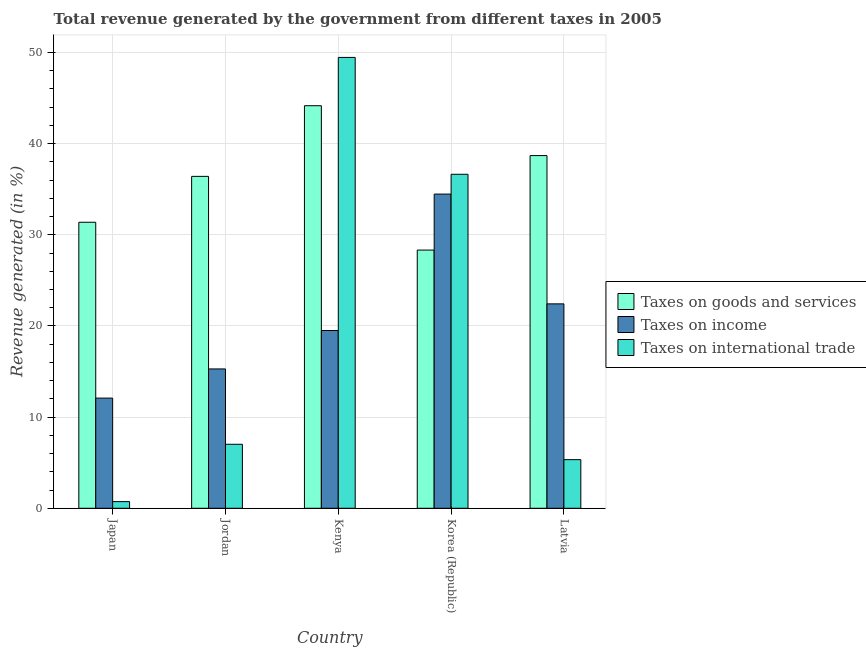How many groups of bars are there?
Give a very brief answer. 5. Are the number of bars per tick equal to the number of legend labels?
Give a very brief answer. Yes. How many bars are there on the 2nd tick from the left?
Keep it short and to the point. 3. How many bars are there on the 1st tick from the right?
Make the answer very short. 3. What is the percentage of revenue generated by taxes on income in Korea (Republic)?
Your answer should be compact. 34.46. Across all countries, what is the maximum percentage of revenue generated by taxes on income?
Offer a very short reply. 34.46. Across all countries, what is the minimum percentage of revenue generated by tax on international trade?
Ensure brevity in your answer.  0.73. In which country was the percentage of revenue generated by tax on international trade maximum?
Your answer should be very brief. Kenya. What is the total percentage of revenue generated by taxes on goods and services in the graph?
Give a very brief answer. 178.95. What is the difference between the percentage of revenue generated by tax on international trade in Japan and that in Korea (Republic)?
Offer a terse response. -35.91. What is the difference between the percentage of revenue generated by taxes on goods and services in Kenya and the percentage of revenue generated by taxes on income in Japan?
Your response must be concise. 32.07. What is the average percentage of revenue generated by taxes on goods and services per country?
Offer a terse response. 35.79. What is the difference between the percentage of revenue generated by taxes on goods and services and percentage of revenue generated by tax on international trade in Latvia?
Provide a succinct answer. 33.35. What is the ratio of the percentage of revenue generated by tax on international trade in Jordan to that in Kenya?
Provide a short and direct response. 0.14. Is the percentage of revenue generated by taxes on goods and services in Kenya less than that in Latvia?
Make the answer very short. No. Is the difference between the percentage of revenue generated by taxes on goods and services in Jordan and Korea (Republic) greater than the difference between the percentage of revenue generated by tax on international trade in Jordan and Korea (Republic)?
Provide a short and direct response. Yes. What is the difference between the highest and the second highest percentage of revenue generated by taxes on goods and services?
Your response must be concise. 5.47. What is the difference between the highest and the lowest percentage of revenue generated by tax on international trade?
Your answer should be very brief. 48.72. Is the sum of the percentage of revenue generated by taxes on goods and services in Japan and Jordan greater than the maximum percentage of revenue generated by taxes on income across all countries?
Provide a succinct answer. Yes. What does the 1st bar from the left in Latvia represents?
Ensure brevity in your answer.  Taxes on goods and services. What does the 3rd bar from the right in Latvia represents?
Your response must be concise. Taxes on goods and services. Is it the case that in every country, the sum of the percentage of revenue generated by taxes on goods and services and percentage of revenue generated by taxes on income is greater than the percentage of revenue generated by tax on international trade?
Provide a short and direct response. Yes. How many bars are there?
Offer a very short reply. 15. Are all the bars in the graph horizontal?
Give a very brief answer. No. How many countries are there in the graph?
Your response must be concise. 5. What is the difference between two consecutive major ticks on the Y-axis?
Offer a very short reply. 10. Are the values on the major ticks of Y-axis written in scientific E-notation?
Your answer should be compact. No. Does the graph contain grids?
Offer a very short reply. Yes. Where does the legend appear in the graph?
Provide a short and direct response. Center right. How many legend labels are there?
Offer a terse response. 3. What is the title of the graph?
Give a very brief answer. Total revenue generated by the government from different taxes in 2005. Does "Tertiary" appear as one of the legend labels in the graph?
Offer a terse response. No. What is the label or title of the X-axis?
Provide a short and direct response. Country. What is the label or title of the Y-axis?
Offer a terse response. Revenue generated (in %). What is the Revenue generated (in %) of Taxes on goods and services in Japan?
Offer a terse response. 31.37. What is the Revenue generated (in %) in Taxes on income in Japan?
Offer a terse response. 12.08. What is the Revenue generated (in %) in Taxes on international trade in Japan?
Keep it short and to the point. 0.73. What is the Revenue generated (in %) in Taxes on goods and services in Jordan?
Your answer should be compact. 36.41. What is the Revenue generated (in %) in Taxes on income in Jordan?
Make the answer very short. 15.28. What is the Revenue generated (in %) of Taxes on international trade in Jordan?
Offer a very short reply. 7.02. What is the Revenue generated (in %) of Taxes on goods and services in Kenya?
Your answer should be very brief. 44.16. What is the Revenue generated (in %) of Taxes on income in Kenya?
Offer a very short reply. 19.5. What is the Revenue generated (in %) of Taxes on international trade in Kenya?
Your response must be concise. 49.45. What is the Revenue generated (in %) in Taxes on goods and services in Korea (Republic)?
Your response must be concise. 28.32. What is the Revenue generated (in %) of Taxes on income in Korea (Republic)?
Your answer should be compact. 34.46. What is the Revenue generated (in %) of Taxes on international trade in Korea (Republic)?
Your answer should be very brief. 36.64. What is the Revenue generated (in %) of Taxes on goods and services in Latvia?
Give a very brief answer. 38.69. What is the Revenue generated (in %) of Taxes on income in Latvia?
Your response must be concise. 22.42. What is the Revenue generated (in %) in Taxes on international trade in Latvia?
Offer a very short reply. 5.33. Across all countries, what is the maximum Revenue generated (in %) of Taxes on goods and services?
Offer a terse response. 44.16. Across all countries, what is the maximum Revenue generated (in %) of Taxes on income?
Give a very brief answer. 34.46. Across all countries, what is the maximum Revenue generated (in %) of Taxes on international trade?
Your response must be concise. 49.45. Across all countries, what is the minimum Revenue generated (in %) in Taxes on goods and services?
Your answer should be very brief. 28.32. Across all countries, what is the minimum Revenue generated (in %) of Taxes on income?
Make the answer very short. 12.08. Across all countries, what is the minimum Revenue generated (in %) in Taxes on international trade?
Provide a succinct answer. 0.73. What is the total Revenue generated (in %) of Taxes on goods and services in the graph?
Offer a very short reply. 178.95. What is the total Revenue generated (in %) of Taxes on income in the graph?
Give a very brief answer. 103.75. What is the total Revenue generated (in %) in Taxes on international trade in the graph?
Give a very brief answer. 99.17. What is the difference between the Revenue generated (in %) in Taxes on goods and services in Japan and that in Jordan?
Provide a short and direct response. -5.03. What is the difference between the Revenue generated (in %) in Taxes on income in Japan and that in Jordan?
Your response must be concise. -3.2. What is the difference between the Revenue generated (in %) of Taxes on international trade in Japan and that in Jordan?
Provide a succinct answer. -6.29. What is the difference between the Revenue generated (in %) in Taxes on goods and services in Japan and that in Kenya?
Keep it short and to the point. -12.78. What is the difference between the Revenue generated (in %) in Taxes on income in Japan and that in Kenya?
Offer a very short reply. -7.41. What is the difference between the Revenue generated (in %) in Taxes on international trade in Japan and that in Kenya?
Keep it short and to the point. -48.73. What is the difference between the Revenue generated (in %) of Taxes on goods and services in Japan and that in Korea (Republic)?
Ensure brevity in your answer.  3.05. What is the difference between the Revenue generated (in %) in Taxes on income in Japan and that in Korea (Republic)?
Give a very brief answer. -22.38. What is the difference between the Revenue generated (in %) of Taxes on international trade in Japan and that in Korea (Republic)?
Give a very brief answer. -35.91. What is the difference between the Revenue generated (in %) of Taxes on goods and services in Japan and that in Latvia?
Give a very brief answer. -7.31. What is the difference between the Revenue generated (in %) in Taxes on income in Japan and that in Latvia?
Ensure brevity in your answer.  -10.34. What is the difference between the Revenue generated (in %) in Taxes on international trade in Japan and that in Latvia?
Offer a very short reply. -4.6. What is the difference between the Revenue generated (in %) of Taxes on goods and services in Jordan and that in Kenya?
Make the answer very short. -7.75. What is the difference between the Revenue generated (in %) of Taxes on income in Jordan and that in Kenya?
Offer a terse response. -4.21. What is the difference between the Revenue generated (in %) in Taxes on international trade in Jordan and that in Kenya?
Keep it short and to the point. -42.44. What is the difference between the Revenue generated (in %) of Taxes on goods and services in Jordan and that in Korea (Republic)?
Give a very brief answer. 8.08. What is the difference between the Revenue generated (in %) of Taxes on income in Jordan and that in Korea (Republic)?
Your answer should be compact. -19.18. What is the difference between the Revenue generated (in %) of Taxes on international trade in Jordan and that in Korea (Republic)?
Your response must be concise. -29.62. What is the difference between the Revenue generated (in %) of Taxes on goods and services in Jordan and that in Latvia?
Give a very brief answer. -2.28. What is the difference between the Revenue generated (in %) in Taxes on income in Jordan and that in Latvia?
Make the answer very short. -7.14. What is the difference between the Revenue generated (in %) of Taxes on international trade in Jordan and that in Latvia?
Your answer should be very brief. 1.69. What is the difference between the Revenue generated (in %) of Taxes on goods and services in Kenya and that in Korea (Republic)?
Your answer should be very brief. 15.83. What is the difference between the Revenue generated (in %) of Taxes on income in Kenya and that in Korea (Republic)?
Provide a short and direct response. -14.97. What is the difference between the Revenue generated (in %) of Taxes on international trade in Kenya and that in Korea (Republic)?
Offer a very short reply. 12.82. What is the difference between the Revenue generated (in %) of Taxes on goods and services in Kenya and that in Latvia?
Offer a very short reply. 5.47. What is the difference between the Revenue generated (in %) in Taxes on income in Kenya and that in Latvia?
Give a very brief answer. -2.93. What is the difference between the Revenue generated (in %) in Taxes on international trade in Kenya and that in Latvia?
Offer a very short reply. 44.12. What is the difference between the Revenue generated (in %) in Taxes on goods and services in Korea (Republic) and that in Latvia?
Provide a succinct answer. -10.36. What is the difference between the Revenue generated (in %) in Taxes on income in Korea (Republic) and that in Latvia?
Offer a very short reply. 12.04. What is the difference between the Revenue generated (in %) of Taxes on international trade in Korea (Republic) and that in Latvia?
Give a very brief answer. 31.3. What is the difference between the Revenue generated (in %) of Taxes on goods and services in Japan and the Revenue generated (in %) of Taxes on income in Jordan?
Offer a very short reply. 16.09. What is the difference between the Revenue generated (in %) of Taxes on goods and services in Japan and the Revenue generated (in %) of Taxes on international trade in Jordan?
Make the answer very short. 24.35. What is the difference between the Revenue generated (in %) in Taxes on income in Japan and the Revenue generated (in %) in Taxes on international trade in Jordan?
Your answer should be very brief. 5.06. What is the difference between the Revenue generated (in %) of Taxes on goods and services in Japan and the Revenue generated (in %) of Taxes on income in Kenya?
Your response must be concise. 11.88. What is the difference between the Revenue generated (in %) of Taxes on goods and services in Japan and the Revenue generated (in %) of Taxes on international trade in Kenya?
Keep it short and to the point. -18.08. What is the difference between the Revenue generated (in %) in Taxes on income in Japan and the Revenue generated (in %) in Taxes on international trade in Kenya?
Your response must be concise. -37.37. What is the difference between the Revenue generated (in %) of Taxes on goods and services in Japan and the Revenue generated (in %) of Taxes on income in Korea (Republic)?
Your response must be concise. -3.09. What is the difference between the Revenue generated (in %) in Taxes on goods and services in Japan and the Revenue generated (in %) in Taxes on international trade in Korea (Republic)?
Make the answer very short. -5.26. What is the difference between the Revenue generated (in %) of Taxes on income in Japan and the Revenue generated (in %) of Taxes on international trade in Korea (Republic)?
Offer a terse response. -24.55. What is the difference between the Revenue generated (in %) of Taxes on goods and services in Japan and the Revenue generated (in %) of Taxes on income in Latvia?
Your answer should be very brief. 8.95. What is the difference between the Revenue generated (in %) in Taxes on goods and services in Japan and the Revenue generated (in %) in Taxes on international trade in Latvia?
Your answer should be very brief. 26.04. What is the difference between the Revenue generated (in %) in Taxes on income in Japan and the Revenue generated (in %) in Taxes on international trade in Latvia?
Give a very brief answer. 6.75. What is the difference between the Revenue generated (in %) in Taxes on goods and services in Jordan and the Revenue generated (in %) in Taxes on income in Kenya?
Make the answer very short. 16.91. What is the difference between the Revenue generated (in %) in Taxes on goods and services in Jordan and the Revenue generated (in %) in Taxes on international trade in Kenya?
Offer a very short reply. -13.05. What is the difference between the Revenue generated (in %) in Taxes on income in Jordan and the Revenue generated (in %) in Taxes on international trade in Kenya?
Your answer should be compact. -34.17. What is the difference between the Revenue generated (in %) in Taxes on goods and services in Jordan and the Revenue generated (in %) in Taxes on income in Korea (Republic)?
Your answer should be very brief. 1.94. What is the difference between the Revenue generated (in %) in Taxes on goods and services in Jordan and the Revenue generated (in %) in Taxes on international trade in Korea (Republic)?
Offer a terse response. -0.23. What is the difference between the Revenue generated (in %) of Taxes on income in Jordan and the Revenue generated (in %) of Taxes on international trade in Korea (Republic)?
Offer a terse response. -21.35. What is the difference between the Revenue generated (in %) of Taxes on goods and services in Jordan and the Revenue generated (in %) of Taxes on income in Latvia?
Give a very brief answer. 13.99. What is the difference between the Revenue generated (in %) of Taxes on goods and services in Jordan and the Revenue generated (in %) of Taxes on international trade in Latvia?
Your answer should be very brief. 31.07. What is the difference between the Revenue generated (in %) in Taxes on income in Jordan and the Revenue generated (in %) in Taxes on international trade in Latvia?
Your answer should be compact. 9.95. What is the difference between the Revenue generated (in %) of Taxes on goods and services in Kenya and the Revenue generated (in %) of Taxes on income in Korea (Republic)?
Provide a short and direct response. 9.69. What is the difference between the Revenue generated (in %) of Taxes on goods and services in Kenya and the Revenue generated (in %) of Taxes on international trade in Korea (Republic)?
Your response must be concise. 7.52. What is the difference between the Revenue generated (in %) of Taxes on income in Kenya and the Revenue generated (in %) of Taxes on international trade in Korea (Republic)?
Give a very brief answer. -17.14. What is the difference between the Revenue generated (in %) of Taxes on goods and services in Kenya and the Revenue generated (in %) of Taxes on income in Latvia?
Provide a short and direct response. 21.74. What is the difference between the Revenue generated (in %) of Taxes on goods and services in Kenya and the Revenue generated (in %) of Taxes on international trade in Latvia?
Keep it short and to the point. 38.82. What is the difference between the Revenue generated (in %) in Taxes on income in Kenya and the Revenue generated (in %) in Taxes on international trade in Latvia?
Make the answer very short. 14.16. What is the difference between the Revenue generated (in %) of Taxes on goods and services in Korea (Republic) and the Revenue generated (in %) of Taxes on income in Latvia?
Ensure brevity in your answer.  5.9. What is the difference between the Revenue generated (in %) of Taxes on goods and services in Korea (Republic) and the Revenue generated (in %) of Taxes on international trade in Latvia?
Your answer should be compact. 22.99. What is the difference between the Revenue generated (in %) in Taxes on income in Korea (Republic) and the Revenue generated (in %) in Taxes on international trade in Latvia?
Provide a succinct answer. 29.13. What is the average Revenue generated (in %) of Taxes on goods and services per country?
Offer a very short reply. 35.79. What is the average Revenue generated (in %) in Taxes on income per country?
Offer a terse response. 20.75. What is the average Revenue generated (in %) in Taxes on international trade per country?
Provide a succinct answer. 19.83. What is the difference between the Revenue generated (in %) of Taxes on goods and services and Revenue generated (in %) of Taxes on income in Japan?
Your answer should be very brief. 19.29. What is the difference between the Revenue generated (in %) in Taxes on goods and services and Revenue generated (in %) in Taxes on international trade in Japan?
Offer a very short reply. 30.64. What is the difference between the Revenue generated (in %) of Taxes on income and Revenue generated (in %) of Taxes on international trade in Japan?
Provide a short and direct response. 11.35. What is the difference between the Revenue generated (in %) of Taxes on goods and services and Revenue generated (in %) of Taxes on income in Jordan?
Offer a very short reply. 21.12. What is the difference between the Revenue generated (in %) in Taxes on goods and services and Revenue generated (in %) in Taxes on international trade in Jordan?
Offer a terse response. 29.39. What is the difference between the Revenue generated (in %) of Taxes on income and Revenue generated (in %) of Taxes on international trade in Jordan?
Your answer should be very brief. 8.26. What is the difference between the Revenue generated (in %) in Taxes on goods and services and Revenue generated (in %) in Taxes on income in Kenya?
Provide a succinct answer. 24.66. What is the difference between the Revenue generated (in %) of Taxes on goods and services and Revenue generated (in %) of Taxes on international trade in Kenya?
Offer a terse response. -5.3. What is the difference between the Revenue generated (in %) of Taxes on income and Revenue generated (in %) of Taxes on international trade in Kenya?
Give a very brief answer. -29.96. What is the difference between the Revenue generated (in %) of Taxes on goods and services and Revenue generated (in %) of Taxes on income in Korea (Republic)?
Ensure brevity in your answer.  -6.14. What is the difference between the Revenue generated (in %) of Taxes on goods and services and Revenue generated (in %) of Taxes on international trade in Korea (Republic)?
Give a very brief answer. -8.31. What is the difference between the Revenue generated (in %) in Taxes on income and Revenue generated (in %) in Taxes on international trade in Korea (Republic)?
Provide a short and direct response. -2.17. What is the difference between the Revenue generated (in %) in Taxes on goods and services and Revenue generated (in %) in Taxes on income in Latvia?
Provide a short and direct response. 16.26. What is the difference between the Revenue generated (in %) of Taxes on goods and services and Revenue generated (in %) of Taxes on international trade in Latvia?
Keep it short and to the point. 33.35. What is the difference between the Revenue generated (in %) of Taxes on income and Revenue generated (in %) of Taxes on international trade in Latvia?
Offer a very short reply. 17.09. What is the ratio of the Revenue generated (in %) in Taxes on goods and services in Japan to that in Jordan?
Provide a short and direct response. 0.86. What is the ratio of the Revenue generated (in %) of Taxes on income in Japan to that in Jordan?
Ensure brevity in your answer.  0.79. What is the ratio of the Revenue generated (in %) of Taxes on international trade in Japan to that in Jordan?
Your answer should be compact. 0.1. What is the ratio of the Revenue generated (in %) of Taxes on goods and services in Japan to that in Kenya?
Ensure brevity in your answer.  0.71. What is the ratio of the Revenue generated (in %) in Taxes on income in Japan to that in Kenya?
Give a very brief answer. 0.62. What is the ratio of the Revenue generated (in %) of Taxes on international trade in Japan to that in Kenya?
Provide a short and direct response. 0.01. What is the ratio of the Revenue generated (in %) of Taxes on goods and services in Japan to that in Korea (Republic)?
Give a very brief answer. 1.11. What is the ratio of the Revenue generated (in %) in Taxes on income in Japan to that in Korea (Republic)?
Ensure brevity in your answer.  0.35. What is the ratio of the Revenue generated (in %) in Taxes on international trade in Japan to that in Korea (Republic)?
Give a very brief answer. 0.02. What is the ratio of the Revenue generated (in %) of Taxes on goods and services in Japan to that in Latvia?
Give a very brief answer. 0.81. What is the ratio of the Revenue generated (in %) in Taxes on income in Japan to that in Latvia?
Your answer should be compact. 0.54. What is the ratio of the Revenue generated (in %) in Taxes on international trade in Japan to that in Latvia?
Provide a succinct answer. 0.14. What is the ratio of the Revenue generated (in %) in Taxes on goods and services in Jordan to that in Kenya?
Keep it short and to the point. 0.82. What is the ratio of the Revenue generated (in %) in Taxes on income in Jordan to that in Kenya?
Your answer should be compact. 0.78. What is the ratio of the Revenue generated (in %) in Taxes on international trade in Jordan to that in Kenya?
Keep it short and to the point. 0.14. What is the ratio of the Revenue generated (in %) in Taxes on goods and services in Jordan to that in Korea (Republic)?
Offer a terse response. 1.29. What is the ratio of the Revenue generated (in %) in Taxes on income in Jordan to that in Korea (Republic)?
Ensure brevity in your answer.  0.44. What is the ratio of the Revenue generated (in %) in Taxes on international trade in Jordan to that in Korea (Republic)?
Your response must be concise. 0.19. What is the ratio of the Revenue generated (in %) of Taxes on goods and services in Jordan to that in Latvia?
Your response must be concise. 0.94. What is the ratio of the Revenue generated (in %) in Taxes on income in Jordan to that in Latvia?
Ensure brevity in your answer.  0.68. What is the ratio of the Revenue generated (in %) of Taxes on international trade in Jordan to that in Latvia?
Keep it short and to the point. 1.32. What is the ratio of the Revenue generated (in %) in Taxes on goods and services in Kenya to that in Korea (Republic)?
Offer a terse response. 1.56. What is the ratio of the Revenue generated (in %) of Taxes on income in Kenya to that in Korea (Republic)?
Your response must be concise. 0.57. What is the ratio of the Revenue generated (in %) in Taxes on international trade in Kenya to that in Korea (Republic)?
Make the answer very short. 1.35. What is the ratio of the Revenue generated (in %) in Taxes on goods and services in Kenya to that in Latvia?
Your answer should be compact. 1.14. What is the ratio of the Revenue generated (in %) of Taxes on income in Kenya to that in Latvia?
Offer a very short reply. 0.87. What is the ratio of the Revenue generated (in %) of Taxes on international trade in Kenya to that in Latvia?
Keep it short and to the point. 9.27. What is the ratio of the Revenue generated (in %) of Taxes on goods and services in Korea (Republic) to that in Latvia?
Ensure brevity in your answer.  0.73. What is the ratio of the Revenue generated (in %) of Taxes on income in Korea (Republic) to that in Latvia?
Provide a short and direct response. 1.54. What is the ratio of the Revenue generated (in %) of Taxes on international trade in Korea (Republic) to that in Latvia?
Give a very brief answer. 6.87. What is the difference between the highest and the second highest Revenue generated (in %) in Taxes on goods and services?
Offer a very short reply. 5.47. What is the difference between the highest and the second highest Revenue generated (in %) of Taxes on income?
Ensure brevity in your answer.  12.04. What is the difference between the highest and the second highest Revenue generated (in %) in Taxes on international trade?
Ensure brevity in your answer.  12.82. What is the difference between the highest and the lowest Revenue generated (in %) of Taxes on goods and services?
Provide a short and direct response. 15.83. What is the difference between the highest and the lowest Revenue generated (in %) in Taxes on income?
Ensure brevity in your answer.  22.38. What is the difference between the highest and the lowest Revenue generated (in %) in Taxes on international trade?
Your answer should be compact. 48.73. 